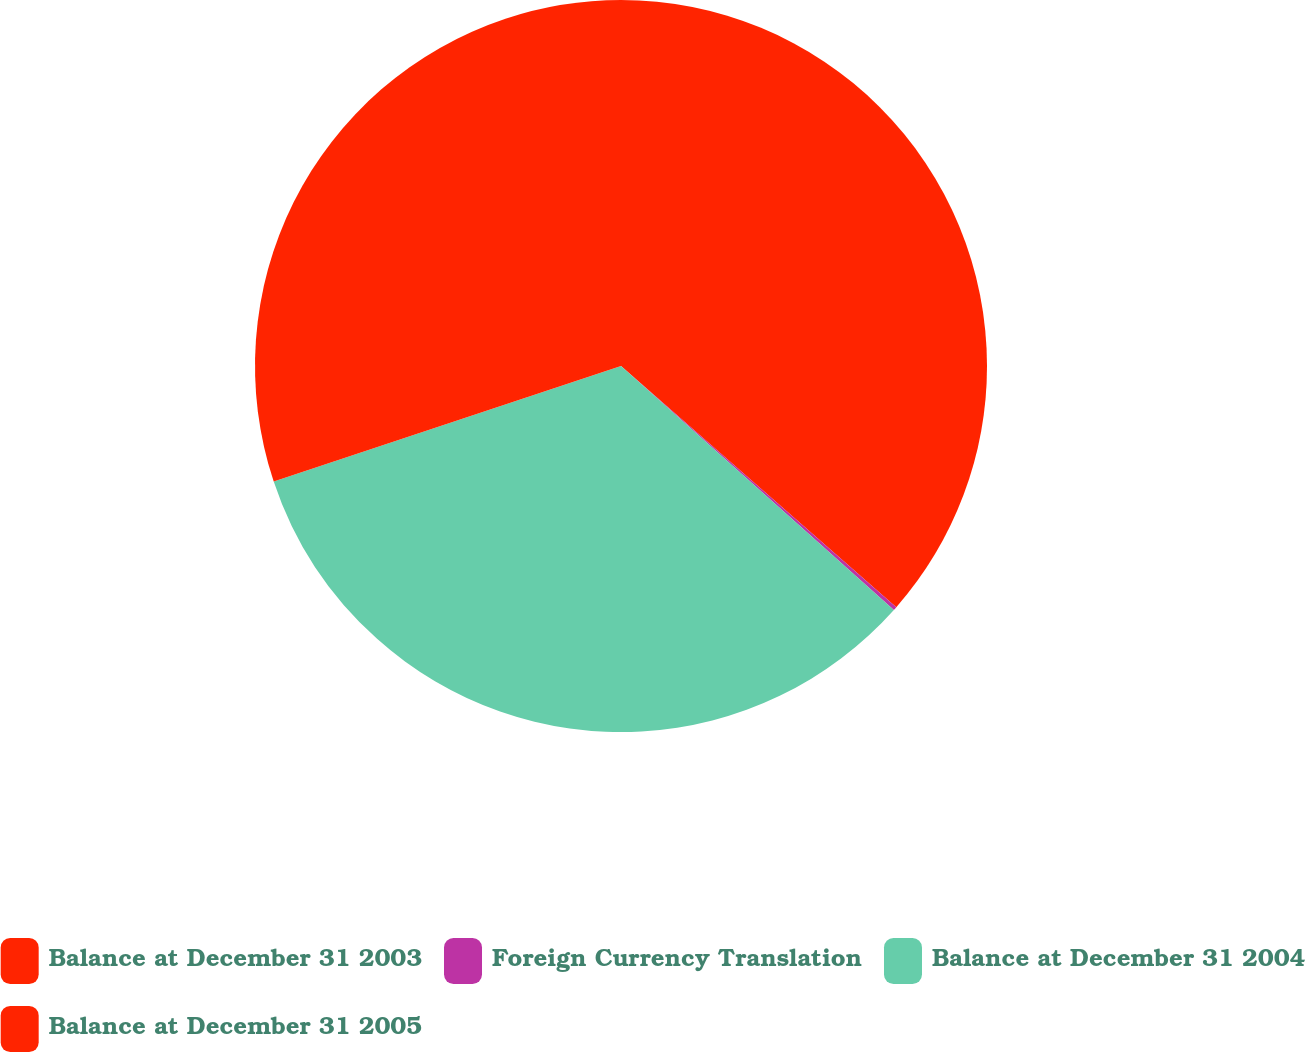Convert chart. <chart><loc_0><loc_0><loc_500><loc_500><pie_chart><fcel>Balance at December 31 2003<fcel>Foreign Currency Translation<fcel>Balance at December 31 2004<fcel>Balance at December 31 2005<nl><fcel>36.45%<fcel>0.16%<fcel>33.28%<fcel>30.11%<nl></chart> 